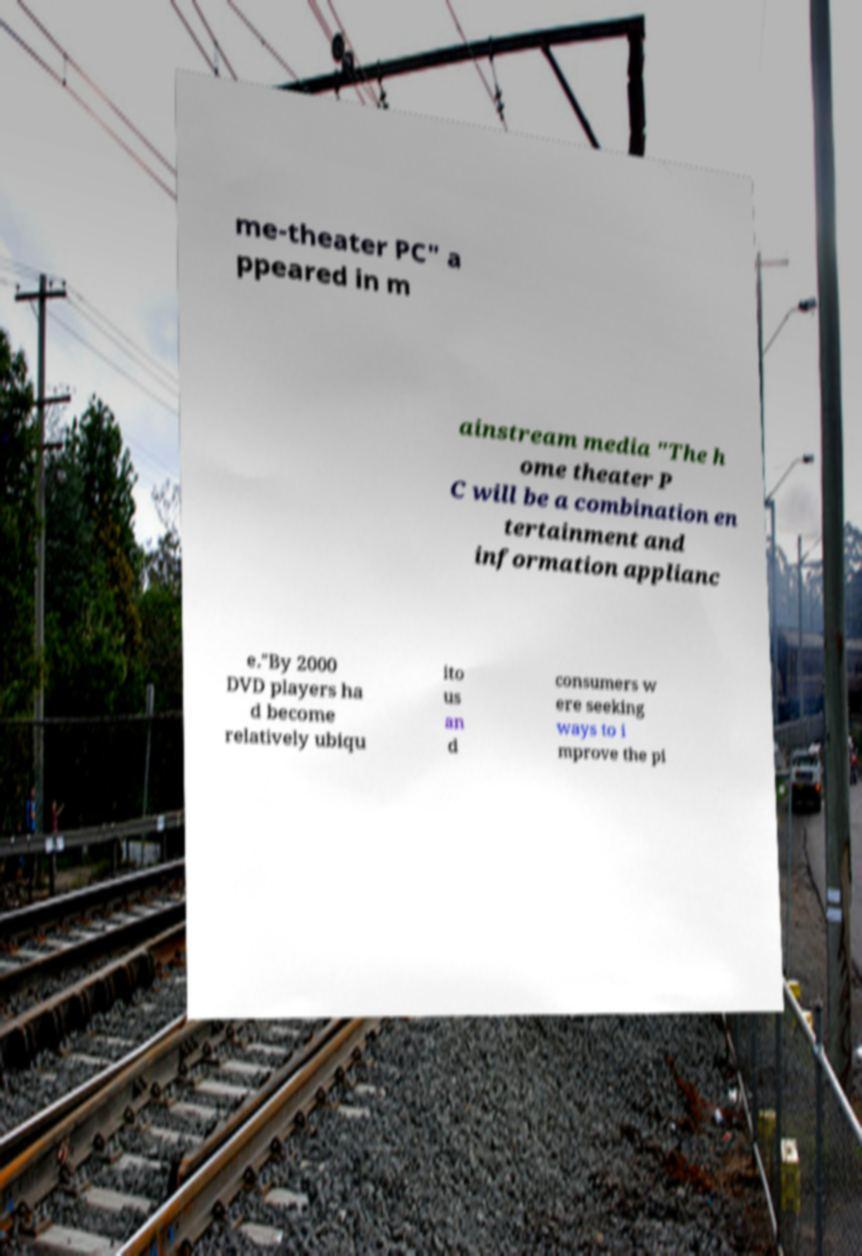Can you read and provide the text displayed in the image?This photo seems to have some interesting text. Can you extract and type it out for me? me-theater PC" a ppeared in m ainstream media "The h ome theater P C will be a combination en tertainment and information applianc e."By 2000 DVD players ha d become relatively ubiqu ito us an d consumers w ere seeking ways to i mprove the pi 